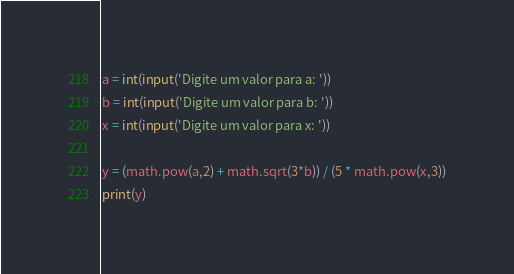<code> <loc_0><loc_0><loc_500><loc_500><_Python_>a = int(input('Digite um valor para a: '))
b = int(input('Digite um valor para b: '))
x = int(input('Digite um valor para x: '))

y = (math.pow(a,2) + math.sqrt(3*b)) / (5 * math.pow(x,3))
print(y)

</code> 